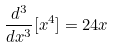<formula> <loc_0><loc_0><loc_500><loc_500>\frac { d ^ { 3 } } { d x ^ { 3 } } [ x ^ { 4 } ] = 2 4 x</formula> 